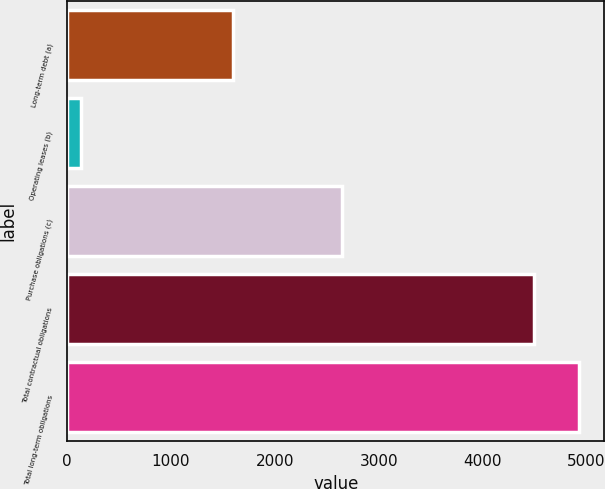Convert chart. <chart><loc_0><loc_0><loc_500><loc_500><bar_chart><fcel>Long-term debt (a)<fcel>Operating leases (b)<fcel>Purchase obligations (c)<fcel>Total contractual obligations<fcel>Total long-term obligations<nl><fcel>1599.8<fcel>137.4<fcel>2646.9<fcel>4492.1<fcel>4927.57<nl></chart> 